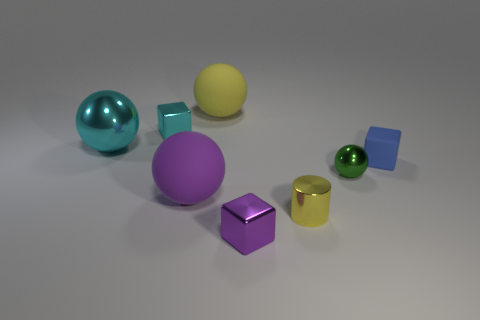Subtract all large cyan metal spheres. How many spheres are left? 3 Subtract 1 spheres. How many spheres are left? 3 Subtract all cyan blocks. How many blocks are left? 2 Add 2 large yellow matte spheres. How many objects exist? 10 Subtract all blue balls. Subtract all gray blocks. How many balls are left? 4 Subtract all cubes. How many objects are left? 5 Add 7 tiny shiny spheres. How many tiny shiny spheres exist? 8 Subtract 0 red blocks. How many objects are left? 8 Subtract all purple rubber things. Subtract all cyan blocks. How many objects are left? 6 Add 4 small yellow shiny objects. How many small yellow shiny objects are left? 5 